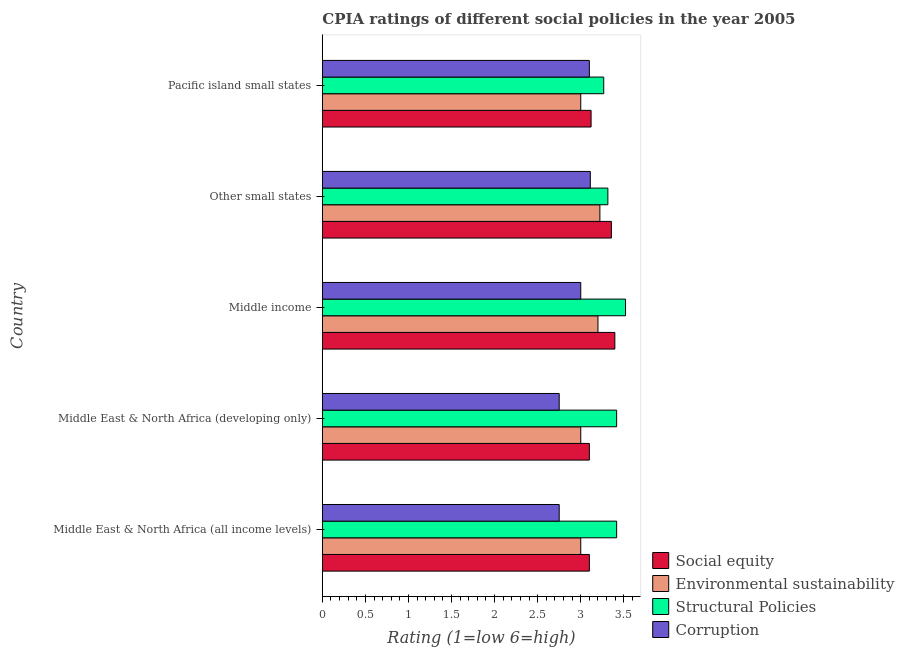How many groups of bars are there?
Keep it short and to the point. 5. Are the number of bars per tick equal to the number of legend labels?
Make the answer very short. Yes. Are the number of bars on each tick of the Y-axis equal?
Offer a very short reply. Yes. What is the label of the 5th group of bars from the top?
Ensure brevity in your answer.  Middle East & North Africa (all income levels). In how many cases, is the number of bars for a given country not equal to the number of legend labels?
Offer a very short reply. 0. What is the cpia rating of social equity in Middle East & North Africa (all income levels)?
Offer a terse response. 3.1. Across all countries, what is the maximum cpia rating of environmental sustainability?
Offer a terse response. 3.22. In which country was the cpia rating of environmental sustainability maximum?
Provide a short and direct response. Other small states. In which country was the cpia rating of structural policies minimum?
Your answer should be compact. Pacific island small states. What is the total cpia rating of corruption in the graph?
Offer a terse response. 14.71. What is the difference between the cpia rating of corruption in Middle East & North Africa (all income levels) and that in Pacific island small states?
Your answer should be very brief. -0.35. What is the difference between the cpia rating of social equity in Pacific island small states and the cpia rating of corruption in Middle income?
Make the answer very short. 0.12. What is the average cpia rating of structural policies per country?
Offer a terse response. 3.39. What is the difference between the cpia rating of corruption and cpia rating of social equity in Pacific island small states?
Make the answer very short. -0.02. In how many countries, is the cpia rating of social equity greater than 2.2 ?
Give a very brief answer. 5. What is the ratio of the cpia rating of social equity in Middle income to that in Pacific island small states?
Your response must be concise. 1.09. Is the cpia rating of environmental sustainability in Middle East & North Africa (developing only) less than that in Pacific island small states?
Your answer should be compact. No. Is the difference between the cpia rating of social equity in Middle income and Pacific island small states greater than the difference between the cpia rating of corruption in Middle income and Pacific island small states?
Provide a short and direct response. Yes. What is the difference between the highest and the second highest cpia rating of social equity?
Offer a terse response. 0.04. In how many countries, is the cpia rating of structural policies greater than the average cpia rating of structural policies taken over all countries?
Your answer should be compact. 3. Is the sum of the cpia rating of social equity in Middle East & North Africa (developing only) and Other small states greater than the maximum cpia rating of environmental sustainability across all countries?
Make the answer very short. Yes. Is it the case that in every country, the sum of the cpia rating of structural policies and cpia rating of social equity is greater than the sum of cpia rating of corruption and cpia rating of environmental sustainability?
Provide a succinct answer. Yes. What does the 4th bar from the top in Middle income represents?
Your answer should be compact. Social equity. What does the 3rd bar from the bottom in Other small states represents?
Give a very brief answer. Structural Policies. Is it the case that in every country, the sum of the cpia rating of social equity and cpia rating of environmental sustainability is greater than the cpia rating of structural policies?
Ensure brevity in your answer.  Yes. What is the difference between two consecutive major ticks on the X-axis?
Your response must be concise. 0.5. Are the values on the major ticks of X-axis written in scientific E-notation?
Provide a short and direct response. No. Does the graph contain grids?
Your answer should be compact. No. Where does the legend appear in the graph?
Your answer should be compact. Bottom right. How many legend labels are there?
Your answer should be compact. 4. What is the title of the graph?
Ensure brevity in your answer.  CPIA ratings of different social policies in the year 2005. What is the Rating (1=low 6=high) of Structural Policies in Middle East & North Africa (all income levels)?
Your answer should be very brief. 3.42. What is the Rating (1=low 6=high) of Corruption in Middle East & North Africa (all income levels)?
Provide a succinct answer. 2.75. What is the Rating (1=low 6=high) in Social equity in Middle East & North Africa (developing only)?
Provide a succinct answer. 3.1. What is the Rating (1=low 6=high) in Structural Policies in Middle East & North Africa (developing only)?
Your response must be concise. 3.42. What is the Rating (1=low 6=high) in Corruption in Middle East & North Africa (developing only)?
Your answer should be compact. 2.75. What is the Rating (1=low 6=high) of Social equity in Middle income?
Provide a short and direct response. 3.4. What is the Rating (1=low 6=high) in Environmental sustainability in Middle income?
Make the answer very short. 3.2. What is the Rating (1=low 6=high) of Structural Policies in Middle income?
Offer a very short reply. 3.52. What is the Rating (1=low 6=high) of Corruption in Middle income?
Keep it short and to the point. 3. What is the Rating (1=low 6=high) of Social equity in Other small states?
Your answer should be very brief. 3.36. What is the Rating (1=low 6=high) in Environmental sustainability in Other small states?
Offer a very short reply. 3.22. What is the Rating (1=low 6=high) in Structural Policies in Other small states?
Give a very brief answer. 3.31. What is the Rating (1=low 6=high) in Corruption in Other small states?
Offer a very short reply. 3.11. What is the Rating (1=low 6=high) of Social equity in Pacific island small states?
Your answer should be compact. 3.12. What is the Rating (1=low 6=high) in Environmental sustainability in Pacific island small states?
Offer a terse response. 3. What is the Rating (1=low 6=high) in Structural Policies in Pacific island small states?
Offer a very short reply. 3.27. What is the Rating (1=low 6=high) in Corruption in Pacific island small states?
Give a very brief answer. 3.1. Across all countries, what is the maximum Rating (1=low 6=high) in Social equity?
Provide a succinct answer. 3.4. Across all countries, what is the maximum Rating (1=low 6=high) of Environmental sustainability?
Offer a very short reply. 3.22. Across all countries, what is the maximum Rating (1=low 6=high) of Structural Policies?
Provide a succinct answer. 3.52. Across all countries, what is the maximum Rating (1=low 6=high) of Corruption?
Your answer should be compact. 3.11. Across all countries, what is the minimum Rating (1=low 6=high) in Environmental sustainability?
Keep it short and to the point. 3. Across all countries, what is the minimum Rating (1=low 6=high) of Structural Policies?
Your answer should be compact. 3.27. Across all countries, what is the minimum Rating (1=low 6=high) of Corruption?
Your response must be concise. 2.75. What is the total Rating (1=low 6=high) of Social equity in the graph?
Your answer should be very brief. 16.07. What is the total Rating (1=low 6=high) of Environmental sustainability in the graph?
Keep it short and to the point. 15.42. What is the total Rating (1=low 6=high) of Structural Policies in the graph?
Ensure brevity in your answer.  16.93. What is the total Rating (1=low 6=high) in Corruption in the graph?
Offer a terse response. 14.71. What is the difference between the Rating (1=low 6=high) of Environmental sustainability in Middle East & North Africa (all income levels) and that in Middle East & North Africa (developing only)?
Your answer should be compact. 0. What is the difference between the Rating (1=low 6=high) of Structural Policies in Middle East & North Africa (all income levels) and that in Middle East & North Africa (developing only)?
Make the answer very short. 0. What is the difference between the Rating (1=low 6=high) of Social equity in Middle East & North Africa (all income levels) and that in Middle income?
Provide a short and direct response. -0.3. What is the difference between the Rating (1=low 6=high) in Environmental sustainability in Middle East & North Africa (all income levels) and that in Middle income?
Keep it short and to the point. -0.2. What is the difference between the Rating (1=low 6=high) of Structural Policies in Middle East & North Africa (all income levels) and that in Middle income?
Ensure brevity in your answer.  -0.1. What is the difference between the Rating (1=low 6=high) in Corruption in Middle East & North Africa (all income levels) and that in Middle income?
Your answer should be compact. -0.25. What is the difference between the Rating (1=low 6=high) in Social equity in Middle East & North Africa (all income levels) and that in Other small states?
Offer a terse response. -0.26. What is the difference between the Rating (1=low 6=high) of Environmental sustainability in Middle East & North Africa (all income levels) and that in Other small states?
Give a very brief answer. -0.22. What is the difference between the Rating (1=low 6=high) of Structural Policies in Middle East & North Africa (all income levels) and that in Other small states?
Offer a very short reply. 0.1. What is the difference between the Rating (1=low 6=high) in Corruption in Middle East & North Africa (all income levels) and that in Other small states?
Offer a terse response. -0.36. What is the difference between the Rating (1=low 6=high) of Social equity in Middle East & North Africa (all income levels) and that in Pacific island small states?
Offer a very short reply. -0.02. What is the difference between the Rating (1=low 6=high) of Corruption in Middle East & North Africa (all income levels) and that in Pacific island small states?
Your response must be concise. -0.35. What is the difference between the Rating (1=low 6=high) of Social equity in Middle East & North Africa (developing only) and that in Middle income?
Offer a very short reply. -0.3. What is the difference between the Rating (1=low 6=high) in Structural Policies in Middle East & North Africa (developing only) and that in Middle income?
Offer a terse response. -0.1. What is the difference between the Rating (1=low 6=high) in Corruption in Middle East & North Africa (developing only) and that in Middle income?
Offer a very short reply. -0.25. What is the difference between the Rating (1=low 6=high) of Social equity in Middle East & North Africa (developing only) and that in Other small states?
Keep it short and to the point. -0.26. What is the difference between the Rating (1=low 6=high) in Environmental sustainability in Middle East & North Africa (developing only) and that in Other small states?
Ensure brevity in your answer.  -0.22. What is the difference between the Rating (1=low 6=high) of Structural Policies in Middle East & North Africa (developing only) and that in Other small states?
Make the answer very short. 0.1. What is the difference between the Rating (1=low 6=high) in Corruption in Middle East & North Africa (developing only) and that in Other small states?
Provide a short and direct response. -0.36. What is the difference between the Rating (1=low 6=high) in Social equity in Middle East & North Africa (developing only) and that in Pacific island small states?
Your answer should be compact. -0.02. What is the difference between the Rating (1=low 6=high) of Corruption in Middle East & North Africa (developing only) and that in Pacific island small states?
Provide a succinct answer. -0.35. What is the difference between the Rating (1=low 6=high) in Social equity in Middle income and that in Other small states?
Offer a terse response. 0.04. What is the difference between the Rating (1=low 6=high) in Environmental sustainability in Middle income and that in Other small states?
Keep it short and to the point. -0.02. What is the difference between the Rating (1=low 6=high) in Structural Policies in Middle income and that in Other small states?
Your answer should be very brief. 0.21. What is the difference between the Rating (1=low 6=high) in Corruption in Middle income and that in Other small states?
Keep it short and to the point. -0.11. What is the difference between the Rating (1=low 6=high) of Social equity in Middle income and that in Pacific island small states?
Keep it short and to the point. 0.28. What is the difference between the Rating (1=low 6=high) in Environmental sustainability in Middle income and that in Pacific island small states?
Ensure brevity in your answer.  0.2. What is the difference between the Rating (1=low 6=high) of Structural Policies in Middle income and that in Pacific island small states?
Provide a succinct answer. 0.25. What is the difference between the Rating (1=low 6=high) in Social equity in Other small states and that in Pacific island small states?
Your response must be concise. 0.24. What is the difference between the Rating (1=low 6=high) in Environmental sustainability in Other small states and that in Pacific island small states?
Keep it short and to the point. 0.22. What is the difference between the Rating (1=low 6=high) in Structural Policies in Other small states and that in Pacific island small states?
Offer a terse response. 0.05. What is the difference between the Rating (1=low 6=high) in Corruption in Other small states and that in Pacific island small states?
Your answer should be very brief. 0.01. What is the difference between the Rating (1=low 6=high) in Social equity in Middle East & North Africa (all income levels) and the Rating (1=low 6=high) in Structural Policies in Middle East & North Africa (developing only)?
Ensure brevity in your answer.  -0.32. What is the difference between the Rating (1=low 6=high) of Social equity in Middle East & North Africa (all income levels) and the Rating (1=low 6=high) of Corruption in Middle East & North Africa (developing only)?
Provide a short and direct response. 0.35. What is the difference between the Rating (1=low 6=high) of Environmental sustainability in Middle East & North Africa (all income levels) and the Rating (1=low 6=high) of Structural Policies in Middle East & North Africa (developing only)?
Give a very brief answer. -0.42. What is the difference between the Rating (1=low 6=high) in Social equity in Middle East & North Africa (all income levels) and the Rating (1=low 6=high) in Structural Policies in Middle income?
Give a very brief answer. -0.42. What is the difference between the Rating (1=low 6=high) of Social equity in Middle East & North Africa (all income levels) and the Rating (1=low 6=high) of Corruption in Middle income?
Your answer should be compact. 0.1. What is the difference between the Rating (1=low 6=high) of Environmental sustainability in Middle East & North Africa (all income levels) and the Rating (1=low 6=high) of Structural Policies in Middle income?
Your answer should be very brief. -0.52. What is the difference between the Rating (1=low 6=high) in Structural Policies in Middle East & North Africa (all income levels) and the Rating (1=low 6=high) in Corruption in Middle income?
Offer a terse response. 0.42. What is the difference between the Rating (1=low 6=high) in Social equity in Middle East & North Africa (all income levels) and the Rating (1=low 6=high) in Environmental sustainability in Other small states?
Offer a very short reply. -0.12. What is the difference between the Rating (1=low 6=high) of Social equity in Middle East & North Africa (all income levels) and the Rating (1=low 6=high) of Structural Policies in Other small states?
Offer a terse response. -0.21. What is the difference between the Rating (1=low 6=high) in Social equity in Middle East & North Africa (all income levels) and the Rating (1=low 6=high) in Corruption in Other small states?
Offer a terse response. -0.01. What is the difference between the Rating (1=low 6=high) in Environmental sustainability in Middle East & North Africa (all income levels) and the Rating (1=low 6=high) in Structural Policies in Other small states?
Offer a very short reply. -0.31. What is the difference between the Rating (1=low 6=high) in Environmental sustainability in Middle East & North Africa (all income levels) and the Rating (1=low 6=high) in Corruption in Other small states?
Make the answer very short. -0.11. What is the difference between the Rating (1=low 6=high) of Structural Policies in Middle East & North Africa (all income levels) and the Rating (1=low 6=high) of Corruption in Other small states?
Offer a very short reply. 0.31. What is the difference between the Rating (1=low 6=high) in Social equity in Middle East & North Africa (all income levels) and the Rating (1=low 6=high) in Environmental sustainability in Pacific island small states?
Give a very brief answer. 0.1. What is the difference between the Rating (1=low 6=high) in Social equity in Middle East & North Africa (all income levels) and the Rating (1=low 6=high) in Structural Policies in Pacific island small states?
Provide a short and direct response. -0.17. What is the difference between the Rating (1=low 6=high) in Social equity in Middle East & North Africa (all income levels) and the Rating (1=low 6=high) in Corruption in Pacific island small states?
Your response must be concise. 0. What is the difference between the Rating (1=low 6=high) of Environmental sustainability in Middle East & North Africa (all income levels) and the Rating (1=low 6=high) of Structural Policies in Pacific island small states?
Your response must be concise. -0.27. What is the difference between the Rating (1=low 6=high) in Structural Policies in Middle East & North Africa (all income levels) and the Rating (1=low 6=high) in Corruption in Pacific island small states?
Your answer should be compact. 0.32. What is the difference between the Rating (1=low 6=high) of Social equity in Middle East & North Africa (developing only) and the Rating (1=low 6=high) of Environmental sustainability in Middle income?
Provide a short and direct response. -0.1. What is the difference between the Rating (1=low 6=high) of Social equity in Middle East & North Africa (developing only) and the Rating (1=low 6=high) of Structural Policies in Middle income?
Your answer should be compact. -0.42. What is the difference between the Rating (1=low 6=high) of Social equity in Middle East & North Africa (developing only) and the Rating (1=low 6=high) of Corruption in Middle income?
Give a very brief answer. 0.1. What is the difference between the Rating (1=low 6=high) of Environmental sustainability in Middle East & North Africa (developing only) and the Rating (1=low 6=high) of Structural Policies in Middle income?
Give a very brief answer. -0.52. What is the difference between the Rating (1=low 6=high) in Environmental sustainability in Middle East & North Africa (developing only) and the Rating (1=low 6=high) in Corruption in Middle income?
Offer a very short reply. 0. What is the difference between the Rating (1=low 6=high) in Structural Policies in Middle East & North Africa (developing only) and the Rating (1=low 6=high) in Corruption in Middle income?
Provide a short and direct response. 0.42. What is the difference between the Rating (1=low 6=high) in Social equity in Middle East & North Africa (developing only) and the Rating (1=low 6=high) in Environmental sustainability in Other small states?
Provide a short and direct response. -0.12. What is the difference between the Rating (1=low 6=high) of Social equity in Middle East & North Africa (developing only) and the Rating (1=low 6=high) of Structural Policies in Other small states?
Offer a terse response. -0.21. What is the difference between the Rating (1=low 6=high) in Social equity in Middle East & North Africa (developing only) and the Rating (1=low 6=high) in Corruption in Other small states?
Ensure brevity in your answer.  -0.01. What is the difference between the Rating (1=low 6=high) of Environmental sustainability in Middle East & North Africa (developing only) and the Rating (1=low 6=high) of Structural Policies in Other small states?
Keep it short and to the point. -0.31. What is the difference between the Rating (1=low 6=high) of Environmental sustainability in Middle East & North Africa (developing only) and the Rating (1=low 6=high) of Corruption in Other small states?
Provide a short and direct response. -0.11. What is the difference between the Rating (1=low 6=high) of Structural Policies in Middle East & North Africa (developing only) and the Rating (1=low 6=high) of Corruption in Other small states?
Provide a short and direct response. 0.31. What is the difference between the Rating (1=low 6=high) in Social equity in Middle East & North Africa (developing only) and the Rating (1=low 6=high) in Structural Policies in Pacific island small states?
Your answer should be compact. -0.17. What is the difference between the Rating (1=low 6=high) in Environmental sustainability in Middle East & North Africa (developing only) and the Rating (1=low 6=high) in Structural Policies in Pacific island small states?
Provide a short and direct response. -0.27. What is the difference between the Rating (1=low 6=high) of Structural Policies in Middle East & North Africa (developing only) and the Rating (1=low 6=high) of Corruption in Pacific island small states?
Keep it short and to the point. 0.32. What is the difference between the Rating (1=low 6=high) in Social equity in Middle income and the Rating (1=low 6=high) in Environmental sustainability in Other small states?
Keep it short and to the point. 0.17. What is the difference between the Rating (1=low 6=high) of Social equity in Middle income and the Rating (1=low 6=high) of Structural Policies in Other small states?
Offer a terse response. 0.08. What is the difference between the Rating (1=low 6=high) in Social equity in Middle income and the Rating (1=low 6=high) in Corruption in Other small states?
Provide a short and direct response. 0.28. What is the difference between the Rating (1=low 6=high) of Environmental sustainability in Middle income and the Rating (1=low 6=high) of Structural Policies in Other small states?
Your answer should be very brief. -0.11. What is the difference between the Rating (1=low 6=high) in Environmental sustainability in Middle income and the Rating (1=low 6=high) in Corruption in Other small states?
Keep it short and to the point. 0.09. What is the difference between the Rating (1=low 6=high) of Structural Policies in Middle income and the Rating (1=low 6=high) of Corruption in Other small states?
Make the answer very short. 0.41. What is the difference between the Rating (1=low 6=high) of Social equity in Middle income and the Rating (1=low 6=high) of Environmental sustainability in Pacific island small states?
Your answer should be very brief. 0.4. What is the difference between the Rating (1=low 6=high) of Social equity in Middle income and the Rating (1=low 6=high) of Structural Policies in Pacific island small states?
Give a very brief answer. 0.13. What is the difference between the Rating (1=low 6=high) of Social equity in Middle income and the Rating (1=low 6=high) of Corruption in Pacific island small states?
Provide a short and direct response. 0.3. What is the difference between the Rating (1=low 6=high) in Environmental sustainability in Middle income and the Rating (1=low 6=high) in Structural Policies in Pacific island small states?
Your response must be concise. -0.07. What is the difference between the Rating (1=low 6=high) of Structural Policies in Middle income and the Rating (1=low 6=high) of Corruption in Pacific island small states?
Offer a very short reply. 0.42. What is the difference between the Rating (1=low 6=high) in Social equity in Other small states and the Rating (1=low 6=high) in Environmental sustainability in Pacific island small states?
Your response must be concise. 0.36. What is the difference between the Rating (1=low 6=high) of Social equity in Other small states and the Rating (1=low 6=high) of Structural Policies in Pacific island small states?
Offer a very short reply. 0.09. What is the difference between the Rating (1=low 6=high) of Social equity in Other small states and the Rating (1=low 6=high) of Corruption in Pacific island small states?
Provide a succinct answer. 0.26. What is the difference between the Rating (1=low 6=high) of Environmental sustainability in Other small states and the Rating (1=low 6=high) of Structural Policies in Pacific island small states?
Offer a very short reply. -0.04. What is the difference between the Rating (1=low 6=high) of Environmental sustainability in Other small states and the Rating (1=low 6=high) of Corruption in Pacific island small states?
Your answer should be very brief. 0.12. What is the difference between the Rating (1=low 6=high) of Structural Policies in Other small states and the Rating (1=low 6=high) of Corruption in Pacific island small states?
Offer a very short reply. 0.21. What is the average Rating (1=low 6=high) in Social equity per country?
Your answer should be very brief. 3.21. What is the average Rating (1=low 6=high) of Environmental sustainability per country?
Keep it short and to the point. 3.08. What is the average Rating (1=low 6=high) of Structural Policies per country?
Offer a terse response. 3.39. What is the average Rating (1=low 6=high) in Corruption per country?
Offer a very short reply. 2.94. What is the difference between the Rating (1=low 6=high) of Social equity and Rating (1=low 6=high) of Environmental sustainability in Middle East & North Africa (all income levels)?
Provide a short and direct response. 0.1. What is the difference between the Rating (1=low 6=high) in Social equity and Rating (1=low 6=high) in Structural Policies in Middle East & North Africa (all income levels)?
Your answer should be compact. -0.32. What is the difference between the Rating (1=low 6=high) in Social equity and Rating (1=low 6=high) in Corruption in Middle East & North Africa (all income levels)?
Keep it short and to the point. 0.35. What is the difference between the Rating (1=low 6=high) of Environmental sustainability and Rating (1=low 6=high) of Structural Policies in Middle East & North Africa (all income levels)?
Provide a short and direct response. -0.42. What is the difference between the Rating (1=low 6=high) in Environmental sustainability and Rating (1=low 6=high) in Corruption in Middle East & North Africa (all income levels)?
Ensure brevity in your answer.  0.25. What is the difference between the Rating (1=low 6=high) of Structural Policies and Rating (1=low 6=high) of Corruption in Middle East & North Africa (all income levels)?
Provide a short and direct response. 0.67. What is the difference between the Rating (1=low 6=high) in Social equity and Rating (1=low 6=high) in Environmental sustainability in Middle East & North Africa (developing only)?
Offer a terse response. 0.1. What is the difference between the Rating (1=low 6=high) in Social equity and Rating (1=low 6=high) in Structural Policies in Middle East & North Africa (developing only)?
Your answer should be compact. -0.32. What is the difference between the Rating (1=low 6=high) of Environmental sustainability and Rating (1=low 6=high) of Structural Policies in Middle East & North Africa (developing only)?
Keep it short and to the point. -0.42. What is the difference between the Rating (1=low 6=high) of Social equity and Rating (1=low 6=high) of Environmental sustainability in Middle income?
Provide a short and direct response. 0.2. What is the difference between the Rating (1=low 6=high) of Social equity and Rating (1=low 6=high) of Structural Policies in Middle income?
Your response must be concise. -0.12. What is the difference between the Rating (1=low 6=high) in Social equity and Rating (1=low 6=high) in Corruption in Middle income?
Ensure brevity in your answer.  0.4. What is the difference between the Rating (1=low 6=high) of Environmental sustainability and Rating (1=low 6=high) of Structural Policies in Middle income?
Provide a succinct answer. -0.32. What is the difference between the Rating (1=low 6=high) in Structural Policies and Rating (1=low 6=high) in Corruption in Middle income?
Give a very brief answer. 0.52. What is the difference between the Rating (1=low 6=high) in Social equity and Rating (1=low 6=high) in Environmental sustainability in Other small states?
Provide a succinct answer. 0.13. What is the difference between the Rating (1=low 6=high) in Social equity and Rating (1=low 6=high) in Structural Policies in Other small states?
Keep it short and to the point. 0.04. What is the difference between the Rating (1=low 6=high) in Social equity and Rating (1=low 6=high) in Corruption in Other small states?
Offer a very short reply. 0.24. What is the difference between the Rating (1=low 6=high) of Environmental sustainability and Rating (1=low 6=high) of Structural Policies in Other small states?
Offer a very short reply. -0.09. What is the difference between the Rating (1=low 6=high) in Structural Policies and Rating (1=low 6=high) in Corruption in Other small states?
Ensure brevity in your answer.  0.2. What is the difference between the Rating (1=low 6=high) of Social equity and Rating (1=low 6=high) of Environmental sustainability in Pacific island small states?
Give a very brief answer. 0.12. What is the difference between the Rating (1=low 6=high) in Social equity and Rating (1=low 6=high) in Structural Policies in Pacific island small states?
Provide a succinct answer. -0.15. What is the difference between the Rating (1=low 6=high) in Environmental sustainability and Rating (1=low 6=high) in Structural Policies in Pacific island small states?
Offer a terse response. -0.27. What is the difference between the Rating (1=low 6=high) in Structural Policies and Rating (1=low 6=high) in Corruption in Pacific island small states?
Your answer should be compact. 0.17. What is the ratio of the Rating (1=low 6=high) of Social equity in Middle East & North Africa (all income levels) to that in Middle East & North Africa (developing only)?
Your answer should be compact. 1. What is the ratio of the Rating (1=low 6=high) in Corruption in Middle East & North Africa (all income levels) to that in Middle East & North Africa (developing only)?
Keep it short and to the point. 1. What is the ratio of the Rating (1=low 6=high) in Social equity in Middle East & North Africa (all income levels) to that in Middle income?
Ensure brevity in your answer.  0.91. What is the ratio of the Rating (1=low 6=high) in Structural Policies in Middle East & North Africa (all income levels) to that in Middle income?
Give a very brief answer. 0.97. What is the ratio of the Rating (1=low 6=high) of Corruption in Middle East & North Africa (all income levels) to that in Middle income?
Provide a short and direct response. 0.92. What is the ratio of the Rating (1=low 6=high) of Social equity in Middle East & North Africa (all income levels) to that in Other small states?
Your response must be concise. 0.92. What is the ratio of the Rating (1=low 6=high) in Structural Policies in Middle East & North Africa (all income levels) to that in Other small states?
Your response must be concise. 1.03. What is the ratio of the Rating (1=low 6=high) of Corruption in Middle East & North Africa (all income levels) to that in Other small states?
Your answer should be very brief. 0.88. What is the ratio of the Rating (1=low 6=high) in Environmental sustainability in Middle East & North Africa (all income levels) to that in Pacific island small states?
Your answer should be very brief. 1. What is the ratio of the Rating (1=low 6=high) of Structural Policies in Middle East & North Africa (all income levels) to that in Pacific island small states?
Ensure brevity in your answer.  1.05. What is the ratio of the Rating (1=low 6=high) in Corruption in Middle East & North Africa (all income levels) to that in Pacific island small states?
Keep it short and to the point. 0.89. What is the ratio of the Rating (1=low 6=high) of Social equity in Middle East & North Africa (developing only) to that in Middle income?
Provide a short and direct response. 0.91. What is the ratio of the Rating (1=low 6=high) of Structural Policies in Middle East & North Africa (developing only) to that in Middle income?
Your response must be concise. 0.97. What is the ratio of the Rating (1=low 6=high) of Corruption in Middle East & North Africa (developing only) to that in Middle income?
Your response must be concise. 0.92. What is the ratio of the Rating (1=low 6=high) in Social equity in Middle East & North Africa (developing only) to that in Other small states?
Offer a terse response. 0.92. What is the ratio of the Rating (1=low 6=high) of Structural Policies in Middle East & North Africa (developing only) to that in Other small states?
Ensure brevity in your answer.  1.03. What is the ratio of the Rating (1=low 6=high) in Corruption in Middle East & North Africa (developing only) to that in Other small states?
Ensure brevity in your answer.  0.88. What is the ratio of the Rating (1=low 6=high) of Social equity in Middle East & North Africa (developing only) to that in Pacific island small states?
Provide a succinct answer. 0.99. What is the ratio of the Rating (1=low 6=high) of Environmental sustainability in Middle East & North Africa (developing only) to that in Pacific island small states?
Keep it short and to the point. 1. What is the ratio of the Rating (1=low 6=high) in Structural Policies in Middle East & North Africa (developing only) to that in Pacific island small states?
Your response must be concise. 1.05. What is the ratio of the Rating (1=low 6=high) of Corruption in Middle East & North Africa (developing only) to that in Pacific island small states?
Ensure brevity in your answer.  0.89. What is the ratio of the Rating (1=low 6=high) in Structural Policies in Middle income to that in Other small states?
Your response must be concise. 1.06. What is the ratio of the Rating (1=low 6=high) of Social equity in Middle income to that in Pacific island small states?
Provide a short and direct response. 1.09. What is the ratio of the Rating (1=low 6=high) in Environmental sustainability in Middle income to that in Pacific island small states?
Give a very brief answer. 1.07. What is the ratio of the Rating (1=low 6=high) in Structural Policies in Middle income to that in Pacific island small states?
Ensure brevity in your answer.  1.08. What is the ratio of the Rating (1=low 6=high) of Corruption in Middle income to that in Pacific island small states?
Make the answer very short. 0.97. What is the ratio of the Rating (1=low 6=high) of Social equity in Other small states to that in Pacific island small states?
Give a very brief answer. 1.08. What is the ratio of the Rating (1=low 6=high) in Environmental sustainability in Other small states to that in Pacific island small states?
Make the answer very short. 1.07. What is the ratio of the Rating (1=low 6=high) in Structural Policies in Other small states to that in Pacific island small states?
Provide a succinct answer. 1.01. What is the difference between the highest and the second highest Rating (1=low 6=high) in Social equity?
Make the answer very short. 0.04. What is the difference between the highest and the second highest Rating (1=low 6=high) in Environmental sustainability?
Ensure brevity in your answer.  0.02. What is the difference between the highest and the second highest Rating (1=low 6=high) of Structural Policies?
Your answer should be very brief. 0.1. What is the difference between the highest and the second highest Rating (1=low 6=high) in Corruption?
Keep it short and to the point. 0.01. What is the difference between the highest and the lowest Rating (1=low 6=high) in Social equity?
Your answer should be very brief. 0.3. What is the difference between the highest and the lowest Rating (1=low 6=high) of Environmental sustainability?
Make the answer very short. 0.22. What is the difference between the highest and the lowest Rating (1=low 6=high) in Structural Policies?
Keep it short and to the point. 0.25. What is the difference between the highest and the lowest Rating (1=low 6=high) in Corruption?
Keep it short and to the point. 0.36. 